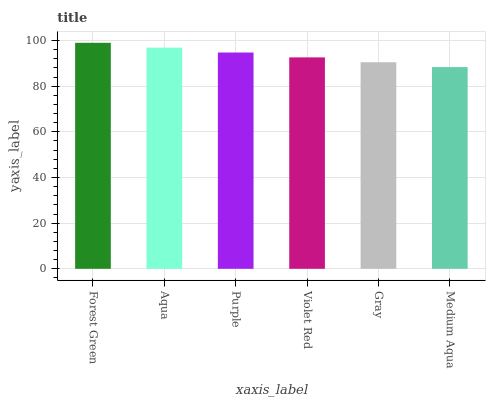Is Medium Aqua the minimum?
Answer yes or no. Yes. Is Forest Green the maximum?
Answer yes or no. Yes. Is Aqua the minimum?
Answer yes or no. No. Is Aqua the maximum?
Answer yes or no. No. Is Forest Green greater than Aqua?
Answer yes or no. Yes. Is Aqua less than Forest Green?
Answer yes or no. Yes. Is Aqua greater than Forest Green?
Answer yes or no. No. Is Forest Green less than Aqua?
Answer yes or no. No. Is Purple the high median?
Answer yes or no. Yes. Is Violet Red the low median?
Answer yes or no. Yes. Is Aqua the high median?
Answer yes or no. No. Is Gray the low median?
Answer yes or no. No. 